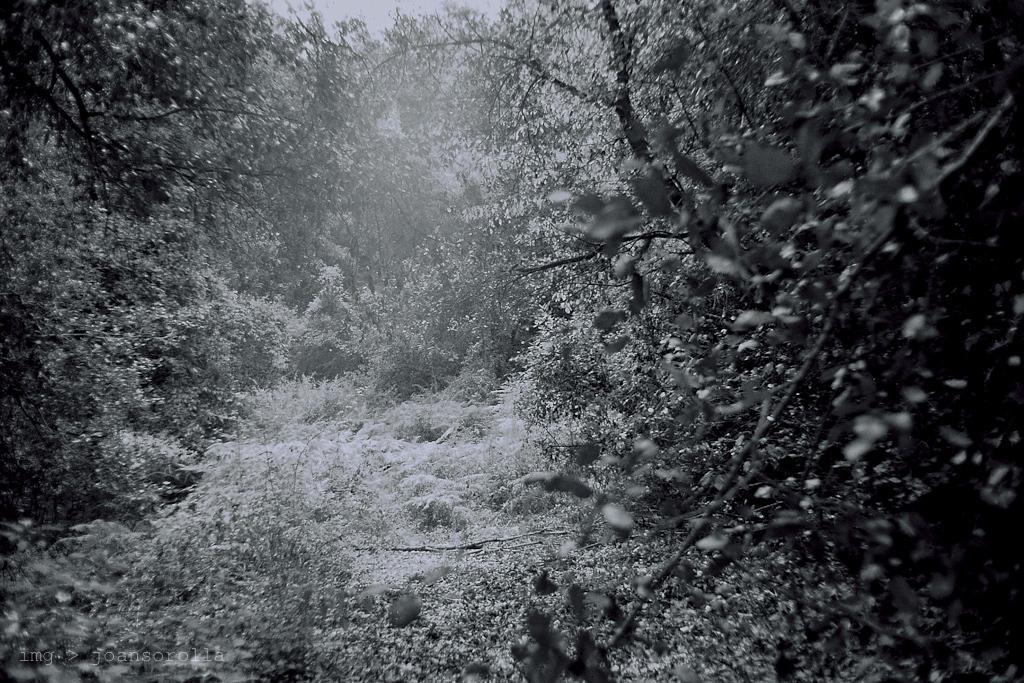Can you describe this image briefly? In the image in the center we can see trees,grass and plants. 